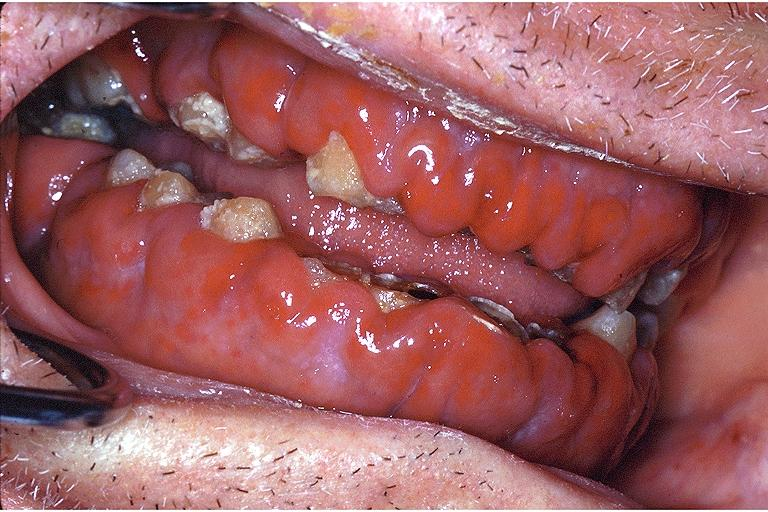does linear fracture in occiput show gingival leukemic infiltrate?
Answer the question using a single word or phrase. No 